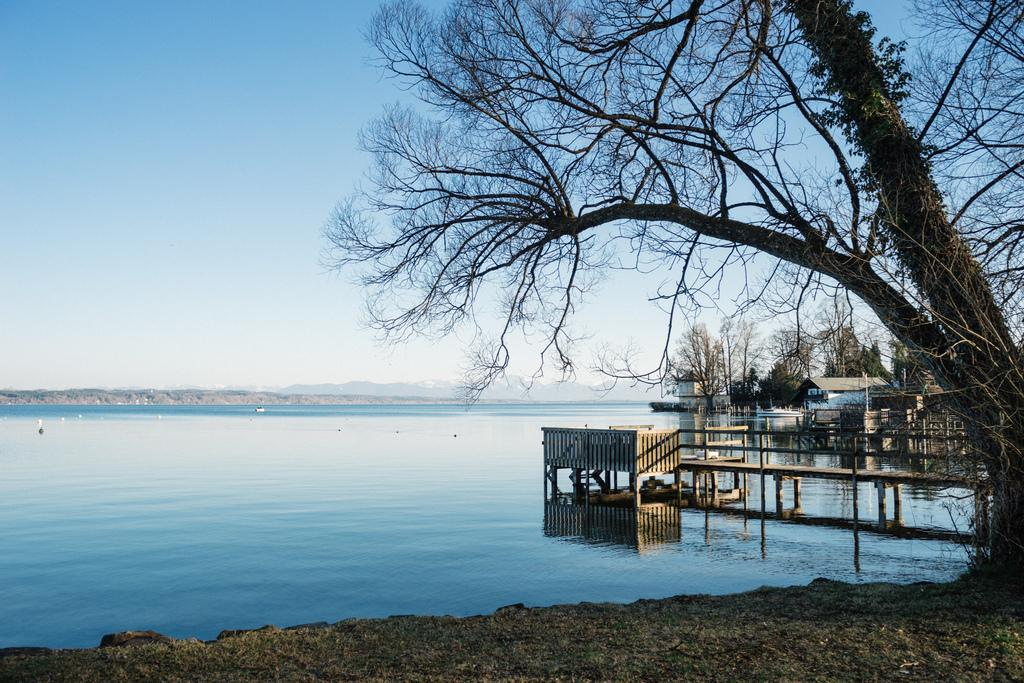What is the main subject in the center of the image? There is water in the center of the image. What can be seen on the right side of the image? There are trees and buildings on the right side of the image. What is the purpose of the platform on the right side of the image? The platform's purpose is not specified in the image, but it could be for viewing the water or for other activities. What is visible in the background of the image? The sky is visible in the background of the image. How many basketballs can be seen on the platform in the image? There are no basketballs present in the image. What type of linen is draped over the trees in the image? There is no linen draped over the trees in the image; only trees and buildings are present. 